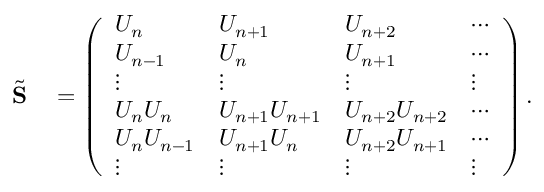<formula> <loc_0><loc_0><loc_500><loc_500>\begin{array} { r l } { \tilde { S } } & = \left ( \begin{array} { l l l l } { U _ { n } } & { U _ { n + 1 } } & { U _ { n + 2 } } & { \cdots } \\ { U _ { n - 1 } } & { U _ { n } } & { U _ { n + 1 } } & { \cdots } \\ { \vdots } & { \vdots } & { \vdots } & { \vdots } \\ { U _ { n } U _ { n } } & { U _ { n + 1 } U _ { n + 1 } } & { U _ { n + 2 } U _ { n + 2 } } & { \cdots } \\ { U _ { n } U _ { n - 1 } } & { U _ { n + 1 } U _ { n } } & { U _ { n + 2 } U _ { n + 1 } } & { \cdots } \\ { \vdots } & { \vdots } & { \vdots } & { \vdots } \end{array} \right ) . } \end{array}</formula> 